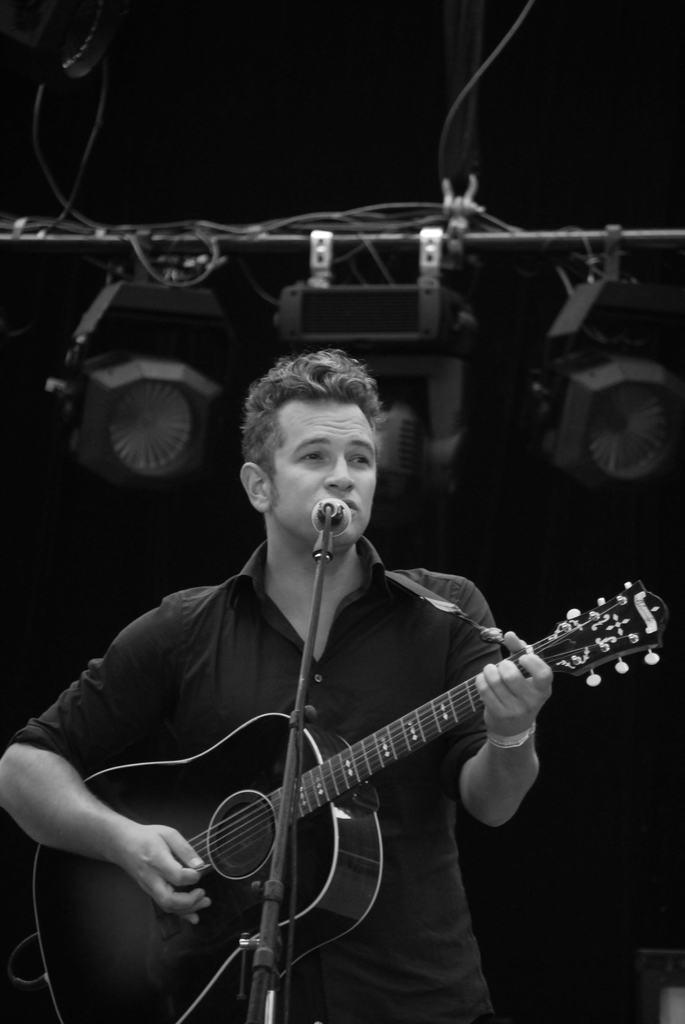What is the man in the image doing? The man is playing a guitar and singing. How is the man amplifying his voice in the image? The man is using a microphone. What can be seen in the background of the image? There is a pole with hanging lights in the background. Can you see any beans or kittens playing with popcorn in the image? No, there are no beans, kittens, or popcorn present in the image. 